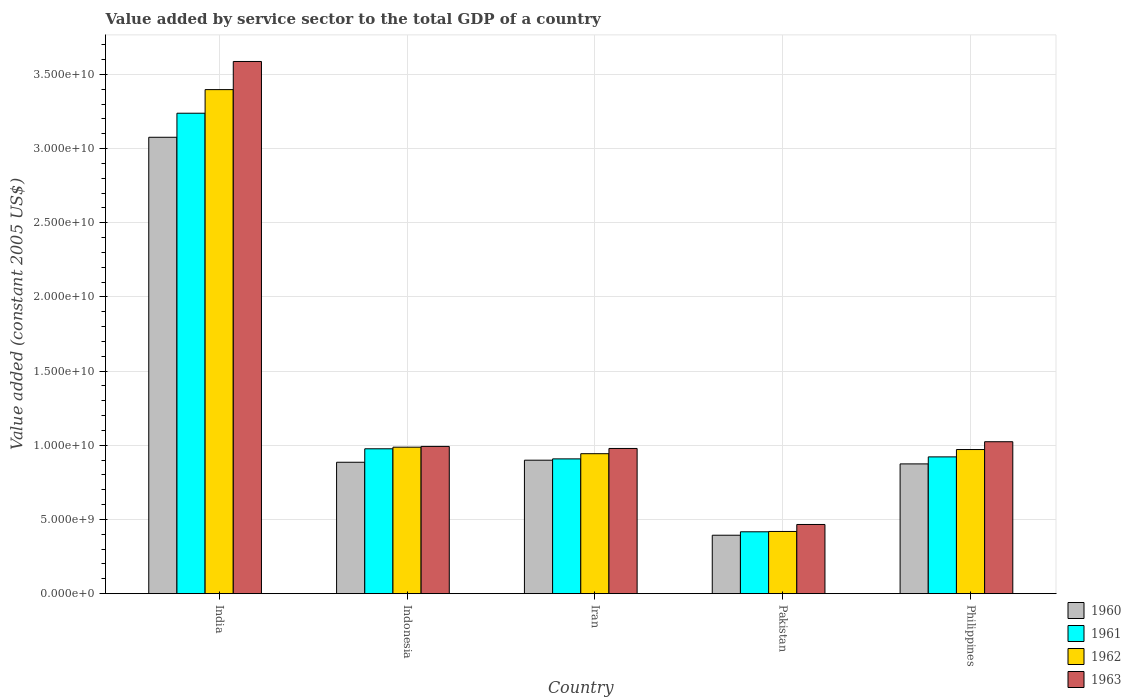How many different coloured bars are there?
Provide a short and direct response. 4. How many groups of bars are there?
Offer a terse response. 5. Are the number of bars per tick equal to the number of legend labels?
Your answer should be compact. Yes. How many bars are there on the 1st tick from the left?
Provide a short and direct response. 4. How many bars are there on the 1st tick from the right?
Your answer should be very brief. 4. What is the label of the 3rd group of bars from the left?
Your answer should be compact. Iran. What is the value added by service sector in 1960 in Philippines?
Provide a short and direct response. 8.75e+09. Across all countries, what is the maximum value added by service sector in 1963?
Your response must be concise. 3.59e+1. Across all countries, what is the minimum value added by service sector in 1961?
Offer a very short reply. 4.17e+09. In which country was the value added by service sector in 1960 maximum?
Your answer should be very brief. India. In which country was the value added by service sector in 1962 minimum?
Give a very brief answer. Pakistan. What is the total value added by service sector in 1963 in the graph?
Provide a short and direct response. 7.05e+1. What is the difference between the value added by service sector in 1960 in Pakistan and that in Philippines?
Provide a short and direct response. -4.81e+09. What is the difference between the value added by service sector in 1961 in India and the value added by service sector in 1962 in Pakistan?
Give a very brief answer. 2.82e+1. What is the average value added by service sector in 1960 per country?
Your answer should be very brief. 1.23e+1. What is the difference between the value added by service sector of/in 1962 and value added by service sector of/in 1961 in Indonesia?
Your answer should be compact. 1.09e+08. In how many countries, is the value added by service sector in 1960 greater than 21000000000 US$?
Offer a terse response. 1. What is the ratio of the value added by service sector in 1962 in India to that in Philippines?
Provide a succinct answer. 3.5. Is the value added by service sector in 1961 in Iran less than that in Philippines?
Offer a terse response. Yes. Is the difference between the value added by service sector in 1962 in Indonesia and Philippines greater than the difference between the value added by service sector in 1961 in Indonesia and Philippines?
Provide a succinct answer. No. What is the difference between the highest and the second highest value added by service sector in 1961?
Your answer should be very brief. 2.26e+1. What is the difference between the highest and the lowest value added by service sector in 1962?
Offer a terse response. 2.98e+1. In how many countries, is the value added by service sector in 1962 greater than the average value added by service sector in 1962 taken over all countries?
Your answer should be compact. 1. Is the sum of the value added by service sector in 1962 in India and Indonesia greater than the maximum value added by service sector in 1961 across all countries?
Offer a very short reply. Yes. Is it the case that in every country, the sum of the value added by service sector in 1961 and value added by service sector in 1963 is greater than the sum of value added by service sector in 1962 and value added by service sector in 1960?
Provide a succinct answer. No. What does the 1st bar from the right in Pakistan represents?
Your answer should be compact. 1963. Is it the case that in every country, the sum of the value added by service sector in 1960 and value added by service sector in 1962 is greater than the value added by service sector in 1963?
Give a very brief answer. Yes. How many bars are there?
Provide a succinct answer. 20. Are all the bars in the graph horizontal?
Keep it short and to the point. No. How many countries are there in the graph?
Offer a terse response. 5. What is the difference between two consecutive major ticks on the Y-axis?
Provide a short and direct response. 5.00e+09. Does the graph contain any zero values?
Provide a succinct answer. No. Does the graph contain grids?
Your answer should be compact. Yes. Where does the legend appear in the graph?
Provide a short and direct response. Bottom right. What is the title of the graph?
Give a very brief answer. Value added by service sector to the total GDP of a country. What is the label or title of the X-axis?
Provide a short and direct response. Country. What is the label or title of the Y-axis?
Make the answer very short. Value added (constant 2005 US$). What is the Value added (constant 2005 US$) of 1960 in India?
Your response must be concise. 3.08e+1. What is the Value added (constant 2005 US$) in 1961 in India?
Make the answer very short. 3.24e+1. What is the Value added (constant 2005 US$) in 1962 in India?
Offer a very short reply. 3.40e+1. What is the Value added (constant 2005 US$) of 1963 in India?
Offer a terse response. 3.59e+1. What is the Value added (constant 2005 US$) in 1960 in Indonesia?
Provide a short and direct response. 8.86e+09. What is the Value added (constant 2005 US$) of 1961 in Indonesia?
Your answer should be compact. 9.77e+09. What is the Value added (constant 2005 US$) in 1962 in Indonesia?
Keep it short and to the point. 9.88e+09. What is the Value added (constant 2005 US$) in 1963 in Indonesia?
Offer a terse response. 9.93e+09. What is the Value added (constant 2005 US$) in 1960 in Iran?
Your response must be concise. 9.00e+09. What is the Value added (constant 2005 US$) of 1961 in Iran?
Your answer should be compact. 9.09e+09. What is the Value added (constant 2005 US$) in 1962 in Iran?
Ensure brevity in your answer.  9.44e+09. What is the Value added (constant 2005 US$) of 1963 in Iran?
Provide a short and direct response. 9.79e+09. What is the Value added (constant 2005 US$) of 1960 in Pakistan?
Your answer should be compact. 3.94e+09. What is the Value added (constant 2005 US$) in 1961 in Pakistan?
Your answer should be very brief. 4.17e+09. What is the Value added (constant 2005 US$) in 1962 in Pakistan?
Make the answer very short. 4.19e+09. What is the Value added (constant 2005 US$) of 1963 in Pakistan?
Your response must be concise. 4.66e+09. What is the Value added (constant 2005 US$) of 1960 in Philippines?
Offer a terse response. 8.75e+09. What is the Value added (constant 2005 US$) in 1961 in Philippines?
Your answer should be compact. 9.22e+09. What is the Value added (constant 2005 US$) in 1962 in Philippines?
Your answer should be compact. 9.72e+09. What is the Value added (constant 2005 US$) in 1963 in Philippines?
Your answer should be very brief. 1.02e+1. Across all countries, what is the maximum Value added (constant 2005 US$) in 1960?
Ensure brevity in your answer.  3.08e+1. Across all countries, what is the maximum Value added (constant 2005 US$) in 1961?
Keep it short and to the point. 3.24e+1. Across all countries, what is the maximum Value added (constant 2005 US$) in 1962?
Provide a succinct answer. 3.40e+1. Across all countries, what is the maximum Value added (constant 2005 US$) in 1963?
Provide a short and direct response. 3.59e+1. Across all countries, what is the minimum Value added (constant 2005 US$) in 1960?
Make the answer very short. 3.94e+09. Across all countries, what is the minimum Value added (constant 2005 US$) in 1961?
Your response must be concise. 4.17e+09. Across all countries, what is the minimum Value added (constant 2005 US$) of 1962?
Ensure brevity in your answer.  4.19e+09. Across all countries, what is the minimum Value added (constant 2005 US$) of 1963?
Your response must be concise. 4.66e+09. What is the total Value added (constant 2005 US$) of 1960 in the graph?
Your answer should be compact. 6.13e+1. What is the total Value added (constant 2005 US$) of 1961 in the graph?
Offer a terse response. 6.46e+1. What is the total Value added (constant 2005 US$) in 1962 in the graph?
Provide a succinct answer. 6.72e+1. What is the total Value added (constant 2005 US$) in 1963 in the graph?
Your response must be concise. 7.05e+1. What is the difference between the Value added (constant 2005 US$) of 1960 in India and that in Indonesia?
Your answer should be very brief. 2.19e+1. What is the difference between the Value added (constant 2005 US$) in 1961 in India and that in Indonesia?
Give a very brief answer. 2.26e+1. What is the difference between the Value added (constant 2005 US$) of 1962 in India and that in Indonesia?
Give a very brief answer. 2.41e+1. What is the difference between the Value added (constant 2005 US$) of 1963 in India and that in Indonesia?
Ensure brevity in your answer.  2.60e+1. What is the difference between the Value added (constant 2005 US$) of 1960 in India and that in Iran?
Your response must be concise. 2.18e+1. What is the difference between the Value added (constant 2005 US$) of 1961 in India and that in Iran?
Your answer should be very brief. 2.33e+1. What is the difference between the Value added (constant 2005 US$) in 1962 in India and that in Iran?
Provide a succinct answer. 2.45e+1. What is the difference between the Value added (constant 2005 US$) of 1963 in India and that in Iran?
Offer a terse response. 2.61e+1. What is the difference between the Value added (constant 2005 US$) in 1960 in India and that in Pakistan?
Ensure brevity in your answer.  2.68e+1. What is the difference between the Value added (constant 2005 US$) of 1961 in India and that in Pakistan?
Give a very brief answer. 2.82e+1. What is the difference between the Value added (constant 2005 US$) of 1962 in India and that in Pakistan?
Provide a short and direct response. 2.98e+1. What is the difference between the Value added (constant 2005 US$) in 1963 in India and that in Pakistan?
Offer a terse response. 3.12e+1. What is the difference between the Value added (constant 2005 US$) of 1960 in India and that in Philippines?
Give a very brief answer. 2.20e+1. What is the difference between the Value added (constant 2005 US$) in 1961 in India and that in Philippines?
Provide a succinct answer. 2.32e+1. What is the difference between the Value added (constant 2005 US$) of 1962 in India and that in Philippines?
Give a very brief answer. 2.43e+1. What is the difference between the Value added (constant 2005 US$) of 1963 in India and that in Philippines?
Provide a short and direct response. 2.56e+1. What is the difference between the Value added (constant 2005 US$) in 1960 in Indonesia and that in Iran?
Provide a succinct answer. -1.39e+08. What is the difference between the Value added (constant 2005 US$) of 1961 in Indonesia and that in Iran?
Your answer should be very brief. 6.80e+08. What is the difference between the Value added (constant 2005 US$) in 1962 in Indonesia and that in Iran?
Offer a very short reply. 4.39e+08. What is the difference between the Value added (constant 2005 US$) of 1963 in Indonesia and that in Iran?
Offer a very short reply. 1.38e+08. What is the difference between the Value added (constant 2005 US$) of 1960 in Indonesia and that in Pakistan?
Offer a very short reply. 4.92e+09. What is the difference between the Value added (constant 2005 US$) in 1961 in Indonesia and that in Pakistan?
Your answer should be compact. 5.60e+09. What is the difference between the Value added (constant 2005 US$) in 1962 in Indonesia and that in Pakistan?
Offer a very short reply. 5.68e+09. What is the difference between the Value added (constant 2005 US$) of 1963 in Indonesia and that in Pakistan?
Provide a short and direct response. 5.26e+09. What is the difference between the Value added (constant 2005 US$) in 1960 in Indonesia and that in Philippines?
Your answer should be very brief. 1.10e+08. What is the difference between the Value added (constant 2005 US$) of 1961 in Indonesia and that in Philippines?
Your answer should be very brief. 5.45e+08. What is the difference between the Value added (constant 2005 US$) of 1962 in Indonesia and that in Philippines?
Your answer should be compact. 1.59e+08. What is the difference between the Value added (constant 2005 US$) of 1963 in Indonesia and that in Philippines?
Your answer should be very brief. -3.16e+08. What is the difference between the Value added (constant 2005 US$) of 1960 in Iran and that in Pakistan?
Your response must be concise. 5.06e+09. What is the difference between the Value added (constant 2005 US$) of 1961 in Iran and that in Pakistan?
Give a very brief answer. 4.92e+09. What is the difference between the Value added (constant 2005 US$) of 1962 in Iran and that in Pakistan?
Keep it short and to the point. 5.24e+09. What is the difference between the Value added (constant 2005 US$) in 1963 in Iran and that in Pakistan?
Provide a succinct answer. 5.12e+09. What is the difference between the Value added (constant 2005 US$) in 1960 in Iran and that in Philippines?
Ensure brevity in your answer.  2.49e+08. What is the difference between the Value added (constant 2005 US$) of 1961 in Iran and that in Philippines?
Your response must be concise. -1.35e+08. What is the difference between the Value added (constant 2005 US$) of 1962 in Iran and that in Philippines?
Keep it short and to the point. -2.80e+08. What is the difference between the Value added (constant 2005 US$) of 1963 in Iran and that in Philippines?
Offer a very short reply. -4.54e+08. What is the difference between the Value added (constant 2005 US$) in 1960 in Pakistan and that in Philippines?
Provide a succinct answer. -4.81e+09. What is the difference between the Value added (constant 2005 US$) in 1961 in Pakistan and that in Philippines?
Ensure brevity in your answer.  -5.05e+09. What is the difference between the Value added (constant 2005 US$) of 1962 in Pakistan and that in Philippines?
Give a very brief answer. -5.52e+09. What is the difference between the Value added (constant 2005 US$) in 1963 in Pakistan and that in Philippines?
Keep it short and to the point. -5.58e+09. What is the difference between the Value added (constant 2005 US$) of 1960 in India and the Value added (constant 2005 US$) of 1961 in Indonesia?
Offer a very short reply. 2.10e+1. What is the difference between the Value added (constant 2005 US$) in 1960 in India and the Value added (constant 2005 US$) in 1962 in Indonesia?
Give a very brief answer. 2.09e+1. What is the difference between the Value added (constant 2005 US$) of 1960 in India and the Value added (constant 2005 US$) of 1963 in Indonesia?
Offer a terse response. 2.08e+1. What is the difference between the Value added (constant 2005 US$) in 1961 in India and the Value added (constant 2005 US$) in 1962 in Indonesia?
Give a very brief answer. 2.25e+1. What is the difference between the Value added (constant 2005 US$) in 1961 in India and the Value added (constant 2005 US$) in 1963 in Indonesia?
Your answer should be compact. 2.25e+1. What is the difference between the Value added (constant 2005 US$) of 1962 in India and the Value added (constant 2005 US$) of 1963 in Indonesia?
Make the answer very short. 2.41e+1. What is the difference between the Value added (constant 2005 US$) in 1960 in India and the Value added (constant 2005 US$) in 1961 in Iran?
Offer a terse response. 2.17e+1. What is the difference between the Value added (constant 2005 US$) of 1960 in India and the Value added (constant 2005 US$) of 1962 in Iran?
Provide a succinct answer. 2.13e+1. What is the difference between the Value added (constant 2005 US$) in 1960 in India and the Value added (constant 2005 US$) in 1963 in Iran?
Offer a terse response. 2.10e+1. What is the difference between the Value added (constant 2005 US$) in 1961 in India and the Value added (constant 2005 US$) in 1962 in Iran?
Your answer should be very brief. 2.30e+1. What is the difference between the Value added (constant 2005 US$) of 1961 in India and the Value added (constant 2005 US$) of 1963 in Iran?
Your answer should be very brief. 2.26e+1. What is the difference between the Value added (constant 2005 US$) in 1962 in India and the Value added (constant 2005 US$) in 1963 in Iran?
Give a very brief answer. 2.42e+1. What is the difference between the Value added (constant 2005 US$) of 1960 in India and the Value added (constant 2005 US$) of 1961 in Pakistan?
Provide a short and direct response. 2.66e+1. What is the difference between the Value added (constant 2005 US$) of 1960 in India and the Value added (constant 2005 US$) of 1962 in Pakistan?
Keep it short and to the point. 2.66e+1. What is the difference between the Value added (constant 2005 US$) of 1960 in India and the Value added (constant 2005 US$) of 1963 in Pakistan?
Provide a succinct answer. 2.61e+1. What is the difference between the Value added (constant 2005 US$) in 1961 in India and the Value added (constant 2005 US$) in 1962 in Pakistan?
Offer a very short reply. 2.82e+1. What is the difference between the Value added (constant 2005 US$) in 1961 in India and the Value added (constant 2005 US$) in 1963 in Pakistan?
Offer a terse response. 2.77e+1. What is the difference between the Value added (constant 2005 US$) in 1962 in India and the Value added (constant 2005 US$) in 1963 in Pakistan?
Provide a succinct answer. 2.93e+1. What is the difference between the Value added (constant 2005 US$) of 1960 in India and the Value added (constant 2005 US$) of 1961 in Philippines?
Your response must be concise. 2.15e+1. What is the difference between the Value added (constant 2005 US$) of 1960 in India and the Value added (constant 2005 US$) of 1962 in Philippines?
Make the answer very short. 2.11e+1. What is the difference between the Value added (constant 2005 US$) in 1960 in India and the Value added (constant 2005 US$) in 1963 in Philippines?
Your answer should be compact. 2.05e+1. What is the difference between the Value added (constant 2005 US$) in 1961 in India and the Value added (constant 2005 US$) in 1962 in Philippines?
Keep it short and to the point. 2.27e+1. What is the difference between the Value added (constant 2005 US$) of 1961 in India and the Value added (constant 2005 US$) of 1963 in Philippines?
Provide a succinct answer. 2.21e+1. What is the difference between the Value added (constant 2005 US$) in 1962 in India and the Value added (constant 2005 US$) in 1963 in Philippines?
Ensure brevity in your answer.  2.37e+1. What is the difference between the Value added (constant 2005 US$) in 1960 in Indonesia and the Value added (constant 2005 US$) in 1961 in Iran?
Offer a very short reply. -2.28e+08. What is the difference between the Value added (constant 2005 US$) in 1960 in Indonesia and the Value added (constant 2005 US$) in 1962 in Iran?
Offer a very short reply. -5.77e+08. What is the difference between the Value added (constant 2005 US$) of 1960 in Indonesia and the Value added (constant 2005 US$) of 1963 in Iran?
Give a very brief answer. -9.30e+08. What is the difference between the Value added (constant 2005 US$) in 1961 in Indonesia and the Value added (constant 2005 US$) in 1962 in Iran?
Keep it short and to the point. 3.30e+08. What is the difference between the Value added (constant 2005 US$) in 1961 in Indonesia and the Value added (constant 2005 US$) in 1963 in Iran?
Make the answer very short. -2.20e+07. What is the difference between the Value added (constant 2005 US$) in 1962 in Indonesia and the Value added (constant 2005 US$) in 1963 in Iran?
Your answer should be very brief. 8.67e+07. What is the difference between the Value added (constant 2005 US$) of 1960 in Indonesia and the Value added (constant 2005 US$) of 1961 in Pakistan?
Keep it short and to the point. 4.69e+09. What is the difference between the Value added (constant 2005 US$) of 1960 in Indonesia and the Value added (constant 2005 US$) of 1962 in Pakistan?
Ensure brevity in your answer.  4.66e+09. What is the difference between the Value added (constant 2005 US$) in 1960 in Indonesia and the Value added (constant 2005 US$) in 1963 in Pakistan?
Offer a very short reply. 4.19e+09. What is the difference between the Value added (constant 2005 US$) in 1961 in Indonesia and the Value added (constant 2005 US$) in 1962 in Pakistan?
Give a very brief answer. 5.57e+09. What is the difference between the Value added (constant 2005 US$) in 1961 in Indonesia and the Value added (constant 2005 US$) in 1963 in Pakistan?
Ensure brevity in your answer.  5.10e+09. What is the difference between the Value added (constant 2005 US$) in 1962 in Indonesia and the Value added (constant 2005 US$) in 1963 in Pakistan?
Your response must be concise. 5.21e+09. What is the difference between the Value added (constant 2005 US$) of 1960 in Indonesia and the Value added (constant 2005 US$) of 1961 in Philippines?
Ensure brevity in your answer.  -3.63e+08. What is the difference between the Value added (constant 2005 US$) in 1960 in Indonesia and the Value added (constant 2005 US$) in 1962 in Philippines?
Ensure brevity in your answer.  -8.58e+08. What is the difference between the Value added (constant 2005 US$) of 1960 in Indonesia and the Value added (constant 2005 US$) of 1963 in Philippines?
Your answer should be very brief. -1.38e+09. What is the difference between the Value added (constant 2005 US$) of 1961 in Indonesia and the Value added (constant 2005 US$) of 1962 in Philippines?
Your answer should be very brief. 5.00e+07. What is the difference between the Value added (constant 2005 US$) in 1961 in Indonesia and the Value added (constant 2005 US$) in 1963 in Philippines?
Your answer should be compact. -4.76e+08. What is the difference between the Value added (constant 2005 US$) in 1962 in Indonesia and the Value added (constant 2005 US$) in 1963 in Philippines?
Your response must be concise. -3.68e+08. What is the difference between the Value added (constant 2005 US$) of 1960 in Iran and the Value added (constant 2005 US$) of 1961 in Pakistan?
Ensure brevity in your answer.  4.83e+09. What is the difference between the Value added (constant 2005 US$) of 1960 in Iran and the Value added (constant 2005 US$) of 1962 in Pakistan?
Ensure brevity in your answer.  4.80e+09. What is the difference between the Value added (constant 2005 US$) of 1960 in Iran and the Value added (constant 2005 US$) of 1963 in Pakistan?
Make the answer very short. 4.33e+09. What is the difference between the Value added (constant 2005 US$) of 1961 in Iran and the Value added (constant 2005 US$) of 1962 in Pakistan?
Offer a very short reply. 4.89e+09. What is the difference between the Value added (constant 2005 US$) in 1961 in Iran and the Value added (constant 2005 US$) in 1963 in Pakistan?
Your answer should be very brief. 4.42e+09. What is the difference between the Value added (constant 2005 US$) of 1962 in Iran and the Value added (constant 2005 US$) of 1963 in Pakistan?
Offer a very short reply. 4.77e+09. What is the difference between the Value added (constant 2005 US$) in 1960 in Iran and the Value added (constant 2005 US$) in 1961 in Philippines?
Make the answer very short. -2.24e+08. What is the difference between the Value added (constant 2005 US$) of 1960 in Iran and the Value added (constant 2005 US$) of 1962 in Philippines?
Ensure brevity in your answer.  -7.19e+08. What is the difference between the Value added (constant 2005 US$) of 1960 in Iran and the Value added (constant 2005 US$) of 1963 in Philippines?
Give a very brief answer. -1.25e+09. What is the difference between the Value added (constant 2005 US$) of 1961 in Iran and the Value added (constant 2005 US$) of 1962 in Philippines?
Provide a succinct answer. -6.30e+08. What is the difference between the Value added (constant 2005 US$) of 1961 in Iran and the Value added (constant 2005 US$) of 1963 in Philippines?
Give a very brief answer. -1.16e+09. What is the difference between the Value added (constant 2005 US$) of 1962 in Iran and the Value added (constant 2005 US$) of 1963 in Philippines?
Offer a terse response. -8.07e+08. What is the difference between the Value added (constant 2005 US$) of 1960 in Pakistan and the Value added (constant 2005 US$) of 1961 in Philippines?
Provide a short and direct response. -5.28e+09. What is the difference between the Value added (constant 2005 US$) in 1960 in Pakistan and the Value added (constant 2005 US$) in 1962 in Philippines?
Your answer should be compact. -5.78e+09. What is the difference between the Value added (constant 2005 US$) of 1960 in Pakistan and the Value added (constant 2005 US$) of 1963 in Philippines?
Your answer should be compact. -6.30e+09. What is the difference between the Value added (constant 2005 US$) in 1961 in Pakistan and the Value added (constant 2005 US$) in 1962 in Philippines?
Offer a very short reply. -5.55e+09. What is the difference between the Value added (constant 2005 US$) in 1961 in Pakistan and the Value added (constant 2005 US$) in 1963 in Philippines?
Give a very brief answer. -6.07e+09. What is the difference between the Value added (constant 2005 US$) of 1962 in Pakistan and the Value added (constant 2005 US$) of 1963 in Philippines?
Your response must be concise. -6.05e+09. What is the average Value added (constant 2005 US$) of 1960 per country?
Your answer should be compact. 1.23e+1. What is the average Value added (constant 2005 US$) in 1961 per country?
Offer a terse response. 1.29e+1. What is the average Value added (constant 2005 US$) of 1962 per country?
Give a very brief answer. 1.34e+1. What is the average Value added (constant 2005 US$) in 1963 per country?
Keep it short and to the point. 1.41e+1. What is the difference between the Value added (constant 2005 US$) of 1960 and Value added (constant 2005 US$) of 1961 in India?
Provide a short and direct response. -1.62e+09. What is the difference between the Value added (constant 2005 US$) of 1960 and Value added (constant 2005 US$) of 1962 in India?
Provide a short and direct response. -3.21e+09. What is the difference between the Value added (constant 2005 US$) of 1960 and Value added (constant 2005 US$) of 1963 in India?
Offer a terse response. -5.11e+09. What is the difference between the Value added (constant 2005 US$) in 1961 and Value added (constant 2005 US$) in 1962 in India?
Keep it short and to the point. -1.59e+09. What is the difference between the Value added (constant 2005 US$) in 1961 and Value added (constant 2005 US$) in 1963 in India?
Keep it short and to the point. -3.49e+09. What is the difference between the Value added (constant 2005 US$) in 1962 and Value added (constant 2005 US$) in 1963 in India?
Keep it short and to the point. -1.90e+09. What is the difference between the Value added (constant 2005 US$) in 1960 and Value added (constant 2005 US$) in 1961 in Indonesia?
Your answer should be very brief. -9.08e+08. What is the difference between the Value added (constant 2005 US$) in 1960 and Value added (constant 2005 US$) in 1962 in Indonesia?
Your response must be concise. -1.02e+09. What is the difference between the Value added (constant 2005 US$) in 1960 and Value added (constant 2005 US$) in 1963 in Indonesia?
Your answer should be compact. -1.07e+09. What is the difference between the Value added (constant 2005 US$) of 1961 and Value added (constant 2005 US$) of 1962 in Indonesia?
Your answer should be very brief. -1.09e+08. What is the difference between the Value added (constant 2005 US$) of 1961 and Value added (constant 2005 US$) of 1963 in Indonesia?
Offer a terse response. -1.60e+08. What is the difference between the Value added (constant 2005 US$) in 1962 and Value added (constant 2005 US$) in 1963 in Indonesia?
Your response must be concise. -5.15e+07. What is the difference between the Value added (constant 2005 US$) of 1960 and Value added (constant 2005 US$) of 1961 in Iran?
Your response must be concise. -8.88e+07. What is the difference between the Value added (constant 2005 US$) of 1960 and Value added (constant 2005 US$) of 1962 in Iran?
Provide a succinct answer. -4.39e+08. What is the difference between the Value added (constant 2005 US$) of 1960 and Value added (constant 2005 US$) of 1963 in Iran?
Your answer should be very brief. -7.91e+08. What is the difference between the Value added (constant 2005 US$) in 1961 and Value added (constant 2005 US$) in 1962 in Iran?
Offer a terse response. -3.50e+08. What is the difference between the Value added (constant 2005 US$) in 1961 and Value added (constant 2005 US$) in 1963 in Iran?
Make the answer very short. -7.02e+08. What is the difference between the Value added (constant 2005 US$) in 1962 and Value added (constant 2005 US$) in 1963 in Iran?
Your answer should be very brief. -3.52e+08. What is the difference between the Value added (constant 2005 US$) of 1960 and Value added (constant 2005 US$) of 1961 in Pakistan?
Your answer should be compact. -2.32e+08. What is the difference between the Value added (constant 2005 US$) in 1960 and Value added (constant 2005 US$) in 1962 in Pakistan?
Offer a very short reply. -2.54e+08. What is the difference between the Value added (constant 2005 US$) of 1960 and Value added (constant 2005 US$) of 1963 in Pakistan?
Ensure brevity in your answer.  -7.25e+08. What is the difference between the Value added (constant 2005 US$) in 1961 and Value added (constant 2005 US$) in 1962 in Pakistan?
Make the answer very short. -2.26e+07. What is the difference between the Value added (constant 2005 US$) of 1961 and Value added (constant 2005 US$) of 1963 in Pakistan?
Your response must be concise. -4.93e+08. What is the difference between the Value added (constant 2005 US$) of 1962 and Value added (constant 2005 US$) of 1963 in Pakistan?
Offer a very short reply. -4.71e+08. What is the difference between the Value added (constant 2005 US$) of 1960 and Value added (constant 2005 US$) of 1961 in Philippines?
Ensure brevity in your answer.  -4.73e+08. What is the difference between the Value added (constant 2005 US$) of 1960 and Value added (constant 2005 US$) of 1962 in Philippines?
Your answer should be very brief. -9.68e+08. What is the difference between the Value added (constant 2005 US$) in 1960 and Value added (constant 2005 US$) in 1963 in Philippines?
Your answer should be compact. -1.49e+09. What is the difference between the Value added (constant 2005 US$) of 1961 and Value added (constant 2005 US$) of 1962 in Philippines?
Provide a succinct answer. -4.95e+08. What is the difference between the Value added (constant 2005 US$) in 1961 and Value added (constant 2005 US$) in 1963 in Philippines?
Make the answer very short. -1.02e+09. What is the difference between the Value added (constant 2005 US$) of 1962 and Value added (constant 2005 US$) of 1963 in Philippines?
Keep it short and to the point. -5.27e+08. What is the ratio of the Value added (constant 2005 US$) in 1960 in India to that in Indonesia?
Make the answer very short. 3.47. What is the ratio of the Value added (constant 2005 US$) of 1961 in India to that in Indonesia?
Give a very brief answer. 3.32. What is the ratio of the Value added (constant 2005 US$) in 1962 in India to that in Indonesia?
Keep it short and to the point. 3.44. What is the ratio of the Value added (constant 2005 US$) in 1963 in India to that in Indonesia?
Offer a very short reply. 3.61. What is the ratio of the Value added (constant 2005 US$) in 1960 in India to that in Iran?
Provide a short and direct response. 3.42. What is the ratio of the Value added (constant 2005 US$) of 1961 in India to that in Iran?
Ensure brevity in your answer.  3.56. What is the ratio of the Value added (constant 2005 US$) of 1962 in India to that in Iran?
Offer a very short reply. 3.6. What is the ratio of the Value added (constant 2005 US$) of 1963 in India to that in Iran?
Your answer should be very brief. 3.67. What is the ratio of the Value added (constant 2005 US$) of 1960 in India to that in Pakistan?
Keep it short and to the point. 7.81. What is the ratio of the Value added (constant 2005 US$) of 1961 in India to that in Pakistan?
Offer a terse response. 7.77. What is the ratio of the Value added (constant 2005 US$) of 1962 in India to that in Pakistan?
Provide a succinct answer. 8.1. What is the ratio of the Value added (constant 2005 US$) in 1963 in India to that in Pakistan?
Ensure brevity in your answer.  7.69. What is the ratio of the Value added (constant 2005 US$) in 1960 in India to that in Philippines?
Keep it short and to the point. 3.52. What is the ratio of the Value added (constant 2005 US$) in 1961 in India to that in Philippines?
Your answer should be compact. 3.51. What is the ratio of the Value added (constant 2005 US$) of 1962 in India to that in Philippines?
Keep it short and to the point. 3.5. What is the ratio of the Value added (constant 2005 US$) in 1963 in India to that in Philippines?
Offer a terse response. 3.5. What is the ratio of the Value added (constant 2005 US$) in 1960 in Indonesia to that in Iran?
Give a very brief answer. 0.98. What is the ratio of the Value added (constant 2005 US$) in 1961 in Indonesia to that in Iran?
Your answer should be compact. 1.07. What is the ratio of the Value added (constant 2005 US$) of 1962 in Indonesia to that in Iran?
Your answer should be very brief. 1.05. What is the ratio of the Value added (constant 2005 US$) in 1963 in Indonesia to that in Iran?
Give a very brief answer. 1.01. What is the ratio of the Value added (constant 2005 US$) of 1960 in Indonesia to that in Pakistan?
Your answer should be very brief. 2.25. What is the ratio of the Value added (constant 2005 US$) in 1961 in Indonesia to that in Pakistan?
Your answer should be compact. 2.34. What is the ratio of the Value added (constant 2005 US$) of 1962 in Indonesia to that in Pakistan?
Your answer should be compact. 2.35. What is the ratio of the Value added (constant 2005 US$) of 1963 in Indonesia to that in Pakistan?
Provide a succinct answer. 2.13. What is the ratio of the Value added (constant 2005 US$) in 1960 in Indonesia to that in Philippines?
Make the answer very short. 1.01. What is the ratio of the Value added (constant 2005 US$) in 1961 in Indonesia to that in Philippines?
Keep it short and to the point. 1.06. What is the ratio of the Value added (constant 2005 US$) in 1962 in Indonesia to that in Philippines?
Give a very brief answer. 1.02. What is the ratio of the Value added (constant 2005 US$) in 1963 in Indonesia to that in Philippines?
Ensure brevity in your answer.  0.97. What is the ratio of the Value added (constant 2005 US$) of 1960 in Iran to that in Pakistan?
Provide a short and direct response. 2.28. What is the ratio of the Value added (constant 2005 US$) of 1961 in Iran to that in Pakistan?
Ensure brevity in your answer.  2.18. What is the ratio of the Value added (constant 2005 US$) of 1962 in Iran to that in Pakistan?
Your answer should be very brief. 2.25. What is the ratio of the Value added (constant 2005 US$) of 1963 in Iran to that in Pakistan?
Your answer should be very brief. 2.1. What is the ratio of the Value added (constant 2005 US$) of 1960 in Iran to that in Philippines?
Offer a terse response. 1.03. What is the ratio of the Value added (constant 2005 US$) of 1961 in Iran to that in Philippines?
Make the answer very short. 0.99. What is the ratio of the Value added (constant 2005 US$) in 1962 in Iran to that in Philippines?
Your response must be concise. 0.97. What is the ratio of the Value added (constant 2005 US$) of 1963 in Iran to that in Philippines?
Your answer should be compact. 0.96. What is the ratio of the Value added (constant 2005 US$) of 1960 in Pakistan to that in Philippines?
Keep it short and to the point. 0.45. What is the ratio of the Value added (constant 2005 US$) of 1961 in Pakistan to that in Philippines?
Keep it short and to the point. 0.45. What is the ratio of the Value added (constant 2005 US$) of 1962 in Pakistan to that in Philippines?
Offer a very short reply. 0.43. What is the ratio of the Value added (constant 2005 US$) of 1963 in Pakistan to that in Philippines?
Provide a succinct answer. 0.46. What is the difference between the highest and the second highest Value added (constant 2005 US$) of 1960?
Offer a terse response. 2.18e+1. What is the difference between the highest and the second highest Value added (constant 2005 US$) of 1961?
Give a very brief answer. 2.26e+1. What is the difference between the highest and the second highest Value added (constant 2005 US$) in 1962?
Provide a short and direct response. 2.41e+1. What is the difference between the highest and the second highest Value added (constant 2005 US$) in 1963?
Give a very brief answer. 2.56e+1. What is the difference between the highest and the lowest Value added (constant 2005 US$) of 1960?
Give a very brief answer. 2.68e+1. What is the difference between the highest and the lowest Value added (constant 2005 US$) of 1961?
Ensure brevity in your answer.  2.82e+1. What is the difference between the highest and the lowest Value added (constant 2005 US$) in 1962?
Give a very brief answer. 2.98e+1. What is the difference between the highest and the lowest Value added (constant 2005 US$) in 1963?
Give a very brief answer. 3.12e+1. 